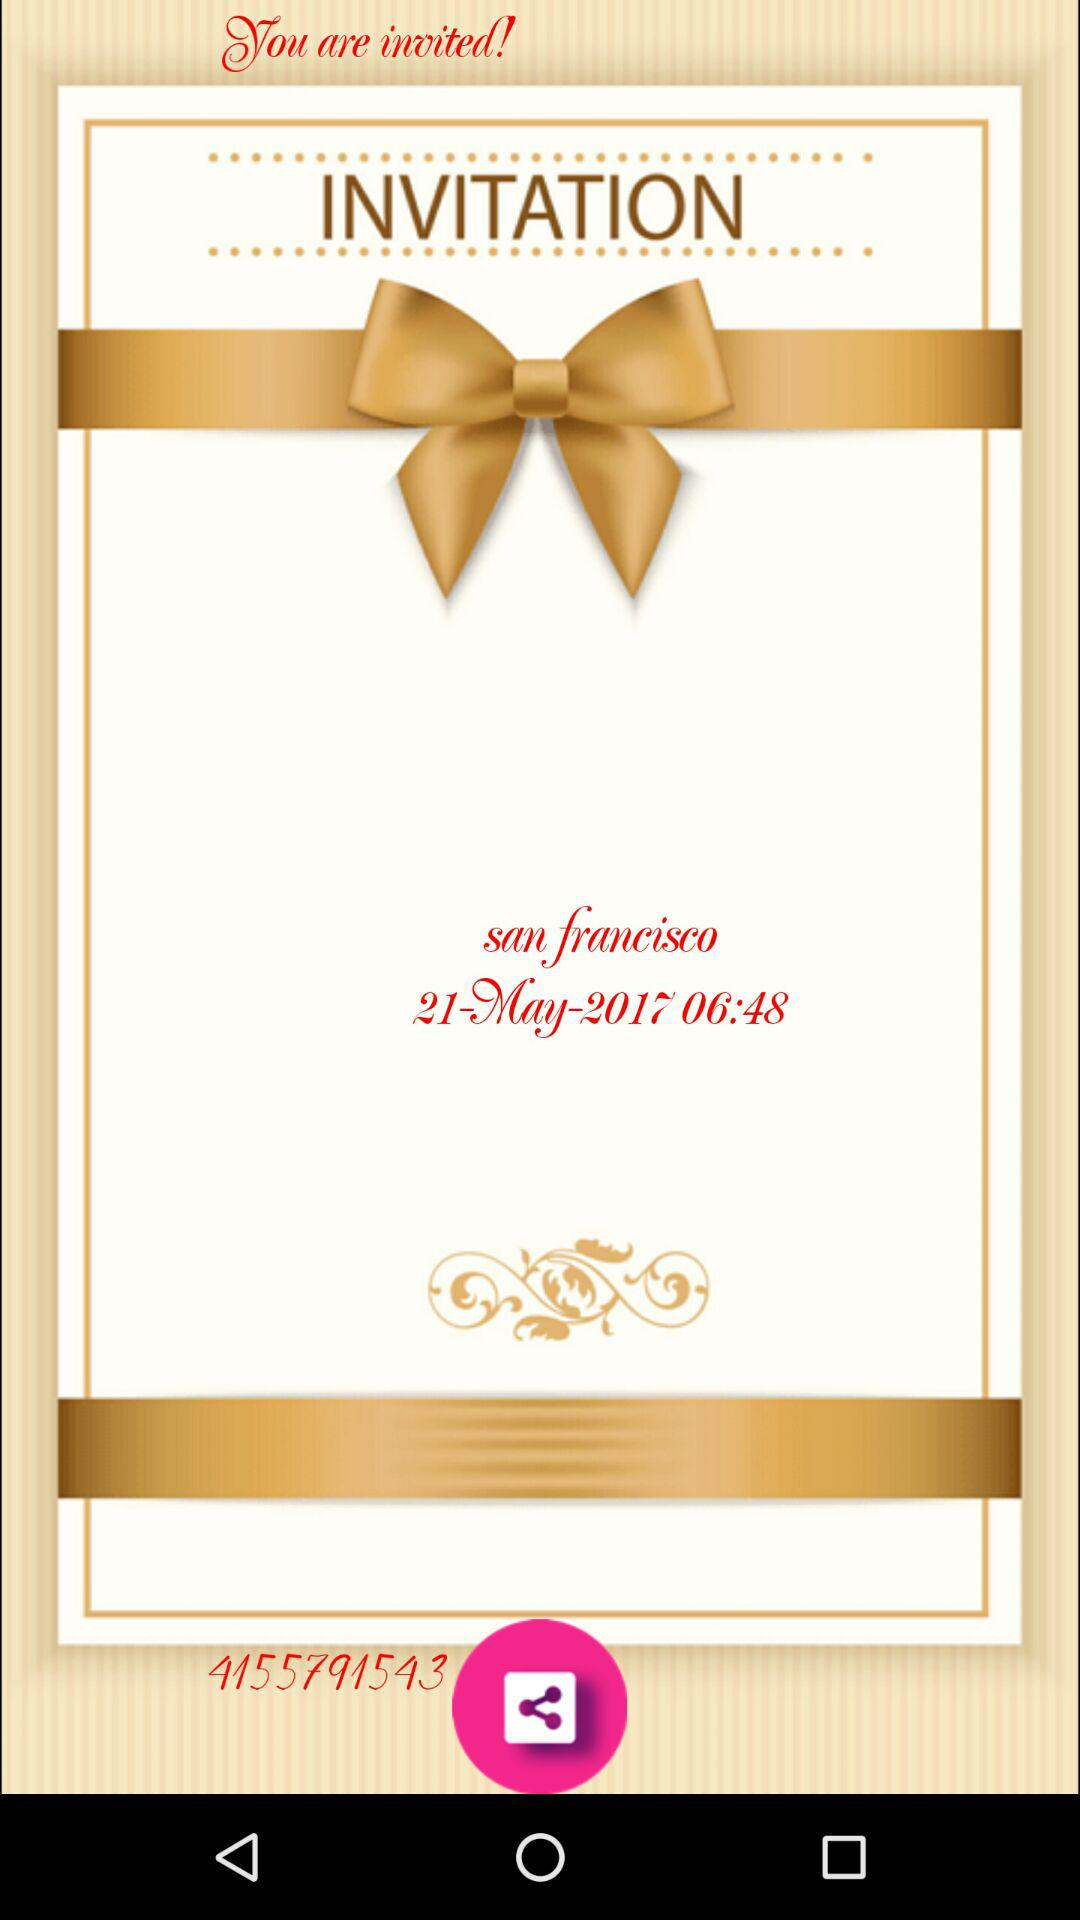What is the location of the invitation? The location of the invitation is San Francisco. 